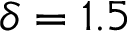<formula> <loc_0><loc_0><loc_500><loc_500>\delta = 1 . 5</formula> 